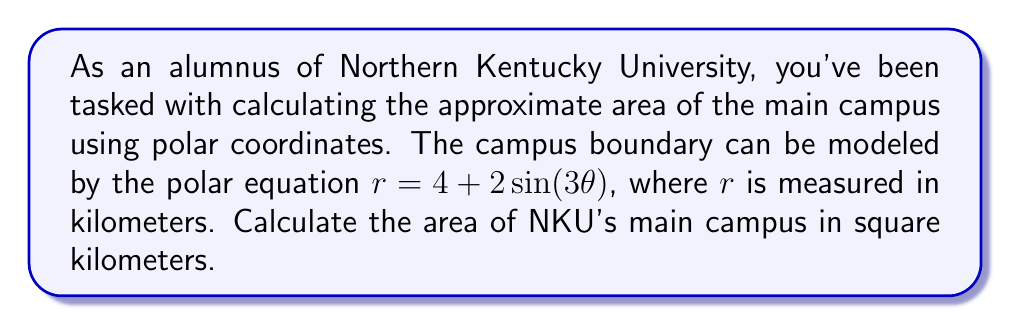Show me your answer to this math problem. To calculate the area enclosed by a polar curve, we use the formula:

$$ A = \frac{1}{2} \int_{0}^{2\pi} r^2(\theta) \, d\theta $$

Where $r(\theta)$ is the given polar equation. In this case, $r(\theta) = 4 + 2\sin(3\theta)$.

Let's follow these steps:

1) Substitute the equation into the formula:

$$ A = \frac{1}{2} \int_{0}^{2\pi} (4 + 2\sin(3\theta))^2 \, d\theta $$

2) Expand the squared term:

$$ A = \frac{1}{2} \int_{0}^{2\pi} (16 + 16\sin(3\theta) + 4\sin^2(3\theta)) \, d\theta $$

3) Separate the integral:

$$ A = \frac{1}{2} \left[ 16 \int_{0}^{2\pi} 1 \, d\theta + 16 \int_{0}^{2\pi} \sin(3\theta) \, d\theta + 4 \int_{0}^{2\pi} \sin^2(3\theta) \, d\theta \right] $$

4) Evaluate each integral:
   - $\int_{0}^{2\pi} 1 \, d\theta = 2\pi$
   - $\int_{0}^{2\pi} \sin(3\theta) \, d\theta = 0$ (sine integrates to zero over a full period)
   - For $\int_{0}^{2\pi} \sin^2(3\theta) \, d\theta$, we can use the identity $\sin^2 x = \frac{1}{2}(1 - \cos(2x))$:
     $\int_{0}^{2\pi} \sin^2(3\theta) \, d\theta = \int_{0}^{2\pi} \frac{1}{2}(1 - \cos(6\theta)) \, d\theta = \pi$

5) Substitute these results:

$$ A = \frac{1}{2} [16(2\pi) + 16(0) + 4(\pi)] = 16\pi + 2\pi = 18\pi $$

Therefore, the area of NKU's main campus is $18\pi$ square kilometers.
Answer: $18\pi$ square kilometers 